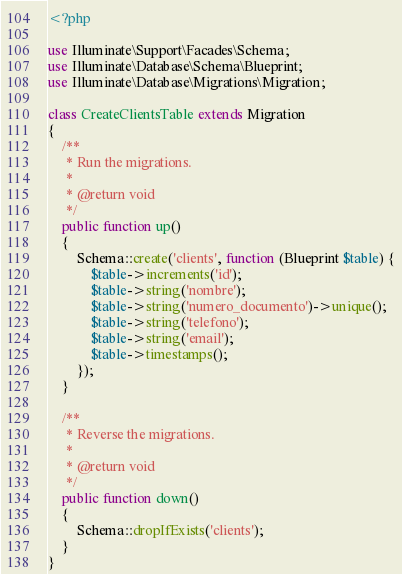Convert code to text. <code><loc_0><loc_0><loc_500><loc_500><_PHP_><?php

use Illuminate\Support\Facades\Schema;
use Illuminate\Database\Schema\Blueprint;
use Illuminate\Database\Migrations\Migration;

class CreateClientsTable extends Migration
{
    /**
     * Run the migrations.
     *
     * @return void
     */
    public function up()
    {
        Schema::create('clients', function (Blueprint $table) {
            $table->increments('id');
            $table->string('nombre');
            $table->string('numero_documento')->unique();
            $table->string('telefono');
            $table->string('email');
            $table->timestamps();
        });
    }

    /**
     * Reverse the migrations.
     *
     * @return void
     */
    public function down()
    {
        Schema::dropIfExists('clients');
    }
}
</code> 